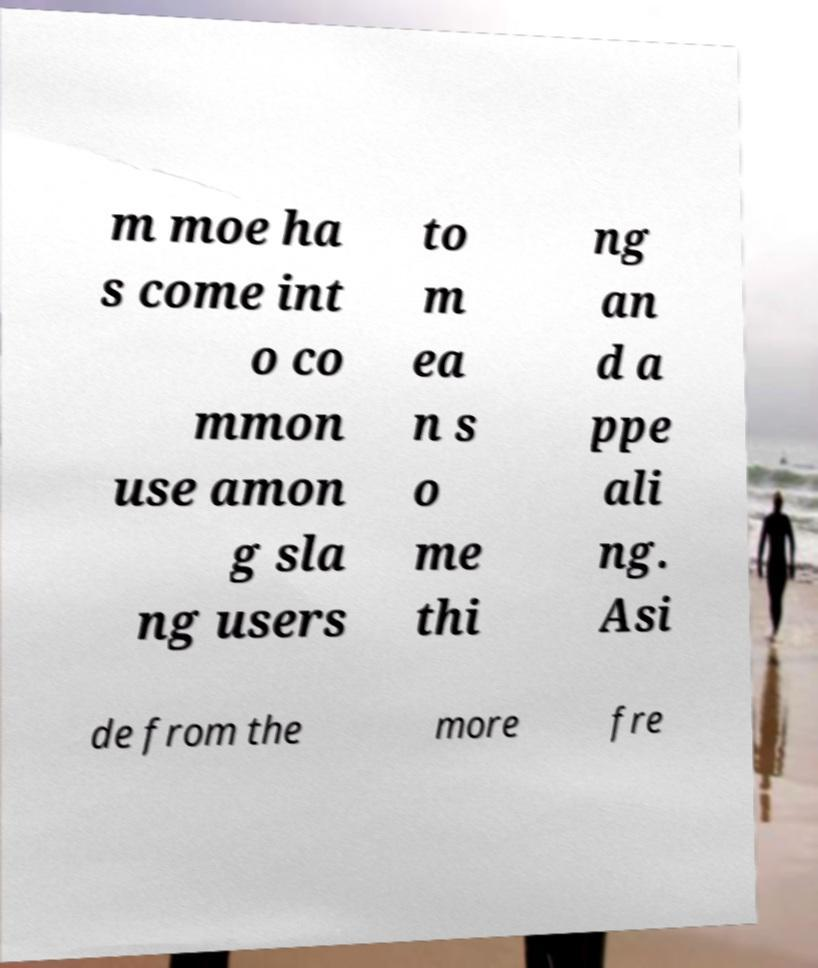Please read and relay the text visible in this image. What does it say? m moe ha s come int o co mmon use amon g sla ng users to m ea n s o me thi ng an d a ppe ali ng. Asi de from the more fre 